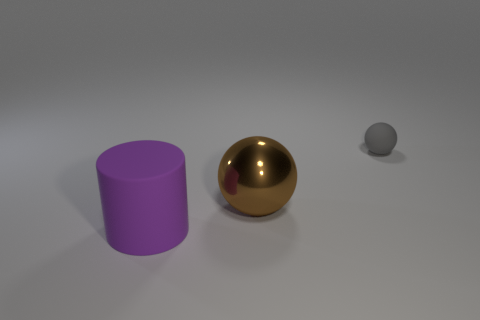Are there more big shiny things behind the big brown shiny ball than tiny gray objects?
Your response must be concise. No. How many brown objects are behind the tiny gray rubber thing behind the shiny sphere?
Give a very brief answer. 0. Is the material of the big object in front of the brown metal object the same as the big thing behind the rubber cylinder?
Offer a terse response. No. What number of other brown objects have the same shape as the tiny object?
Offer a terse response. 1. Is the cylinder made of the same material as the object on the right side of the brown shiny ball?
Keep it short and to the point. Yes. There is a cylinder that is the same size as the brown sphere; what material is it?
Keep it short and to the point. Rubber. Is there another rubber cylinder that has the same size as the purple cylinder?
Keep it short and to the point. No. What is the shape of the purple matte thing that is the same size as the brown ball?
Provide a short and direct response. Cylinder. What number of other things are there of the same color as the tiny ball?
Your answer should be very brief. 0. There is a thing that is behind the purple matte object and in front of the matte sphere; what shape is it?
Your answer should be compact. Sphere. 